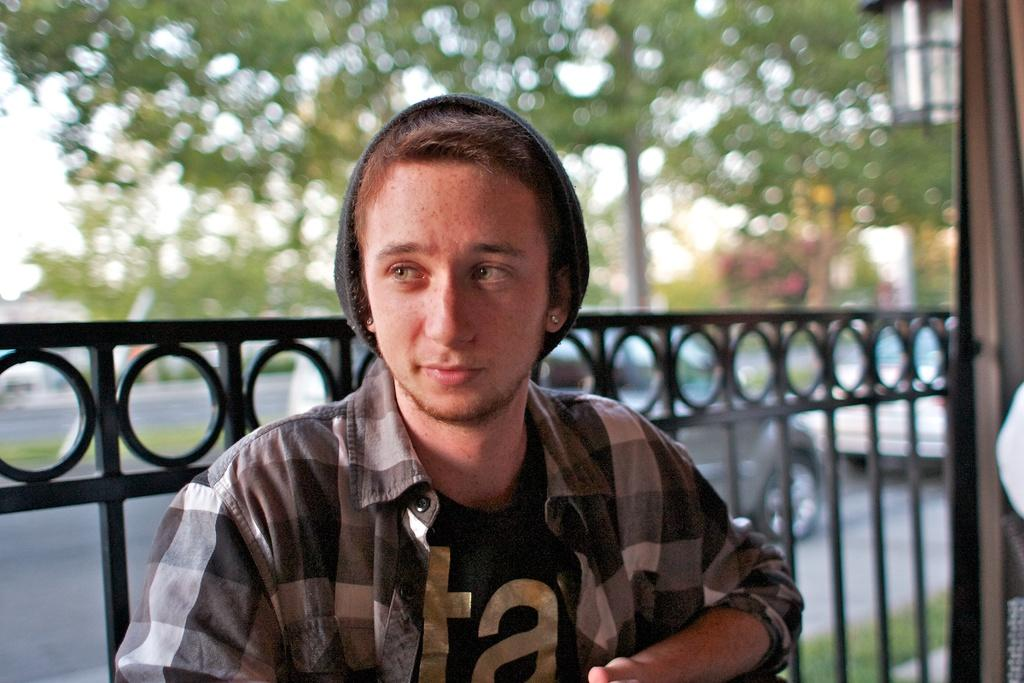What can be seen in the image? There is a person in the image. Can you describe the person's clothing? The person is wearing a black and white shirt and a black cap. What else is visible in the image? There is railing, vehicles on the road, trees with green color, and the sky is white in the image. What type of harmony is being played by the person in the image? There is no indication of music or harmony in the image; it only shows a person wearing a black and white shirt and a black cap, along with other elements like railing, vehicles, trees, and the sky. 